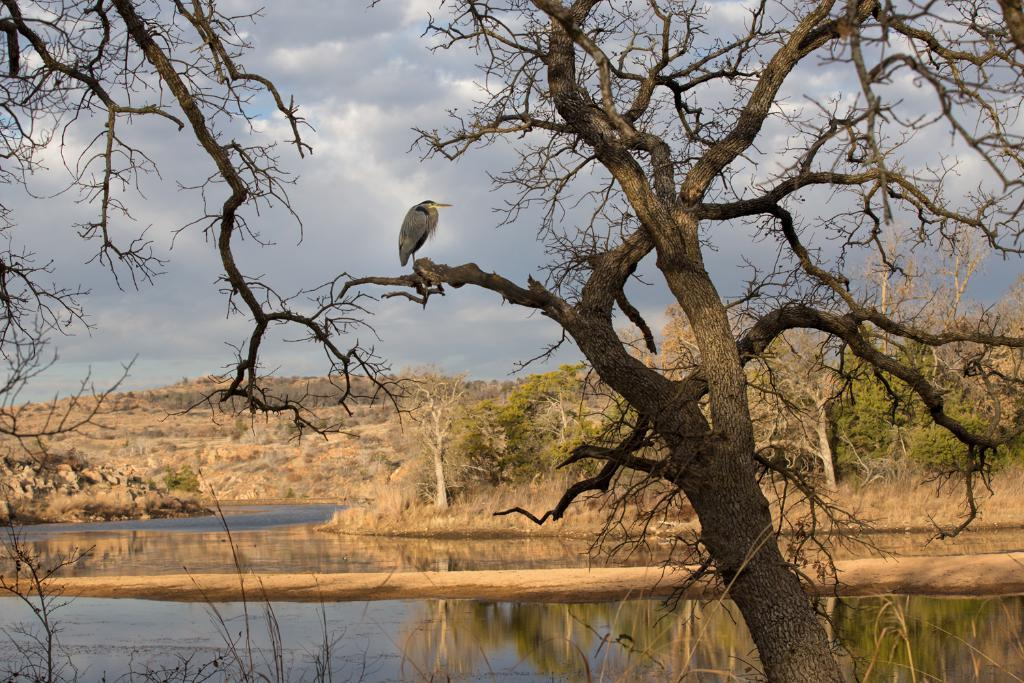What is one of the natural elements present in the image? There is water in the image. What type of vegetation can be seen in the image? There are trees in the image. What can be seen in the sky in the image? Clouds and the sky are visible in the image. Can you describe the bird in the image? There is a grey-colored bird on a branch in the image. What is reflected in the water in the image? There is a reflection in the water in the image. What type of watch is the ladybug wearing in the image? There is no ladybug present in the image, and therefore no watch can be observed. 